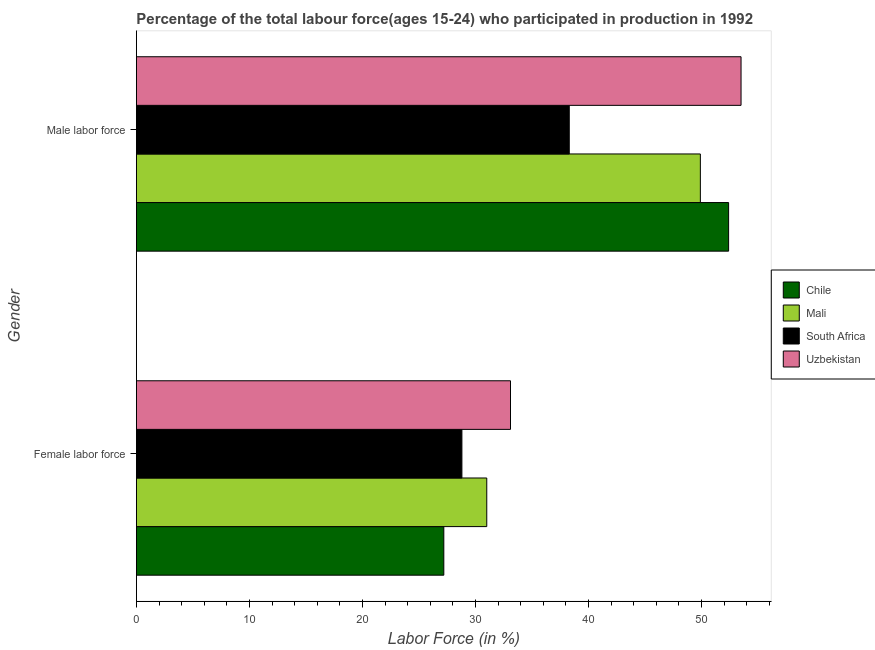How many groups of bars are there?
Keep it short and to the point. 2. Are the number of bars on each tick of the Y-axis equal?
Your answer should be compact. Yes. What is the label of the 2nd group of bars from the top?
Ensure brevity in your answer.  Female labor force. Across all countries, what is the maximum percentage of female labor force?
Offer a very short reply. 33.1. Across all countries, what is the minimum percentage of male labour force?
Offer a very short reply. 38.3. In which country was the percentage of male labour force maximum?
Give a very brief answer. Uzbekistan. What is the total percentage of male labour force in the graph?
Provide a succinct answer. 194.1. What is the difference between the percentage of female labor force in South Africa and that in Mali?
Make the answer very short. -2.2. What is the difference between the percentage of female labor force in Chile and the percentage of male labour force in South Africa?
Offer a terse response. -11.1. What is the average percentage of female labor force per country?
Your answer should be compact. 30.02. What is the difference between the percentage of male labour force and percentage of female labor force in Chile?
Ensure brevity in your answer.  25.2. What is the ratio of the percentage of male labour force in Chile to that in South Africa?
Provide a succinct answer. 1.37. Is the percentage of male labour force in Chile less than that in South Africa?
Provide a short and direct response. No. In how many countries, is the percentage of female labor force greater than the average percentage of female labor force taken over all countries?
Offer a terse response. 2. What does the 2nd bar from the top in Male labor force represents?
Offer a terse response. South Africa. What does the 2nd bar from the bottom in Male labor force represents?
Your answer should be very brief. Mali. What is the difference between two consecutive major ticks on the X-axis?
Ensure brevity in your answer.  10. Does the graph contain any zero values?
Your answer should be compact. No. Does the graph contain grids?
Your response must be concise. No. Where does the legend appear in the graph?
Offer a terse response. Center right. How are the legend labels stacked?
Make the answer very short. Vertical. What is the title of the graph?
Keep it short and to the point. Percentage of the total labour force(ages 15-24) who participated in production in 1992. What is the label or title of the Y-axis?
Offer a terse response. Gender. What is the Labor Force (in %) of Chile in Female labor force?
Make the answer very short. 27.2. What is the Labor Force (in %) in South Africa in Female labor force?
Offer a very short reply. 28.8. What is the Labor Force (in %) in Uzbekistan in Female labor force?
Provide a succinct answer. 33.1. What is the Labor Force (in %) of Chile in Male labor force?
Your response must be concise. 52.4. What is the Labor Force (in %) in Mali in Male labor force?
Keep it short and to the point. 49.9. What is the Labor Force (in %) in South Africa in Male labor force?
Provide a succinct answer. 38.3. What is the Labor Force (in %) of Uzbekistan in Male labor force?
Your answer should be compact. 53.5. Across all Gender, what is the maximum Labor Force (in %) of Chile?
Offer a terse response. 52.4. Across all Gender, what is the maximum Labor Force (in %) of Mali?
Keep it short and to the point. 49.9. Across all Gender, what is the maximum Labor Force (in %) in South Africa?
Offer a terse response. 38.3. Across all Gender, what is the maximum Labor Force (in %) in Uzbekistan?
Your response must be concise. 53.5. Across all Gender, what is the minimum Labor Force (in %) in Chile?
Provide a succinct answer. 27.2. Across all Gender, what is the minimum Labor Force (in %) in South Africa?
Your response must be concise. 28.8. Across all Gender, what is the minimum Labor Force (in %) in Uzbekistan?
Provide a short and direct response. 33.1. What is the total Labor Force (in %) of Chile in the graph?
Your response must be concise. 79.6. What is the total Labor Force (in %) of Mali in the graph?
Your answer should be compact. 80.9. What is the total Labor Force (in %) of South Africa in the graph?
Your answer should be compact. 67.1. What is the total Labor Force (in %) in Uzbekistan in the graph?
Make the answer very short. 86.6. What is the difference between the Labor Force (in %) of Chile in Female labor force and that in Male labor force?
Your answer should be compact. -25.2. What is the difference between the Labor Force (in %) in Mali in Female labor force and that in Male labor force?
Your answer should be compact. -18.9. What is the difference between the Labor Force (in %) in South Africa in Female labor force and that in Male labor force?
Your answer should be very brief. -9.5. What is the difference between the Labor Force (in %) of Uzbekistan in Female labor force and that in Male labor force?
Make the answer very short. -20.4. What is the difference between the Labor Force (in %) of Chile in Female labor force and the Labor Force (in %) of Mali in Male labor force?
Offer a very short reply. -22.7. What is the difference between the Labor Force (in %) of Chile in Female labor force and the Labor Force (in %) of South Africa in Male labor force?
Provide a short and direct response. -11.1. What is the difference between the Labor Force (in %) of Chile in Female labor force and the Labor Force (in %) of Uzbekistan in Male labor force?
Offer a very short reply. -26.3. What is the difference between the Labor Force (in %) of Mali in Female labor force and the Labor Force (in %) of Uzbekistan in Male labor force?
Offer a very short reply. -22.5. What is the difference between the Labor Force (in %) in South Africa in Female labor force and the Labor Force (in %) in Uzbekistan in Male labor force?
Keep it short and to the point. -24.7. What is the average Labor Force (in %) of Chile per Gender?
Make the answer very short. 39.8. What is the average Labor Force (in %) of Mali per Gender?
Provide a succinct answer. 40.45. What is the average Labor Force (in %) of South Africa per Gender?
Make the answer very short. 33.55. What is the average Labor Force (in %) of Uzbekistan per Gender?
Ensure brevity in your answer.  43.3. What is the difference between the Labor Force (in %) of Chile and Labor Force (in %) of Mali in Female labor force?
Provide a succinct answer. -3.8. What is the difference between the Labor Force (in %) of Chile and Labor Force (in %) of Uzbekistan in Female labor force?
Your answer should be very brief. -5.9. What is the difference between the Labor Force (in %) of Mali and Labor Force (in %) of Uzbekistan in Female labor force?
Your response must be concise. -2.1. What is the difference between the Labor Force (in %) of Chile and Labor Force (in %) of South Africa in Male labor force?
Provide a succinct answer. 14.1. What is the difference between the Labor Force (in %) of Mali and Labor Force (in %) of South Africa in Male labor force?
Provide a succinct answer. 11.6. What is the difference between the Labor Force (in %) in South Africa and Labor Force (in %) in Uzbekistan in Male labor force?
Offer a very short reply. -15.2. What is the ratio of the Labor Force (in %) of Chile in Female labor force to that in Male labor force?
Offer a terse response. 0.52. What is the ratio of the Labor Force (in %) of Mali in Female labor force to that in Male labor force?
Give a very brief answer. 0.62. What is the ratio of the Labor Force (in %) of South Africa in Female labor force to that in Male labor force?
Your answer should be compact. 0.75. What is the ratio of the Labor Force (in %) of Uzbekistan in Female labor force to that in Male labor force?
Your answer should be compact. 0.62. What is the difference between the highest and the second highest Labor Force (in %) in Chile?
Give a very brief answer. 25.2. What is the difference between the highest and the second highest Labor Force (in %) in Mali?
Offer a very short reply. 18.9. What is the difference between the highest and the second highest Labor Force (in %) in Uzbekistan?
Give a very brief answer. 20.4. What is the difference between the highest and the lowest Labor Force (in %) of Chile?
Give a very brief answer. 25.2. What is the difference between the highest and the lowest Labor Force (in %) in Mali?
Ensure brevity in your answer.  18.9. What is the difference between the highest and the lowest Labor Force (in %) of South Africa?
Offer a very short reply. 9.5. What is the difference between the highest and the lowest Labor Force (in %) of Uzbekistan?
Offer a very short reply. 20.4. 